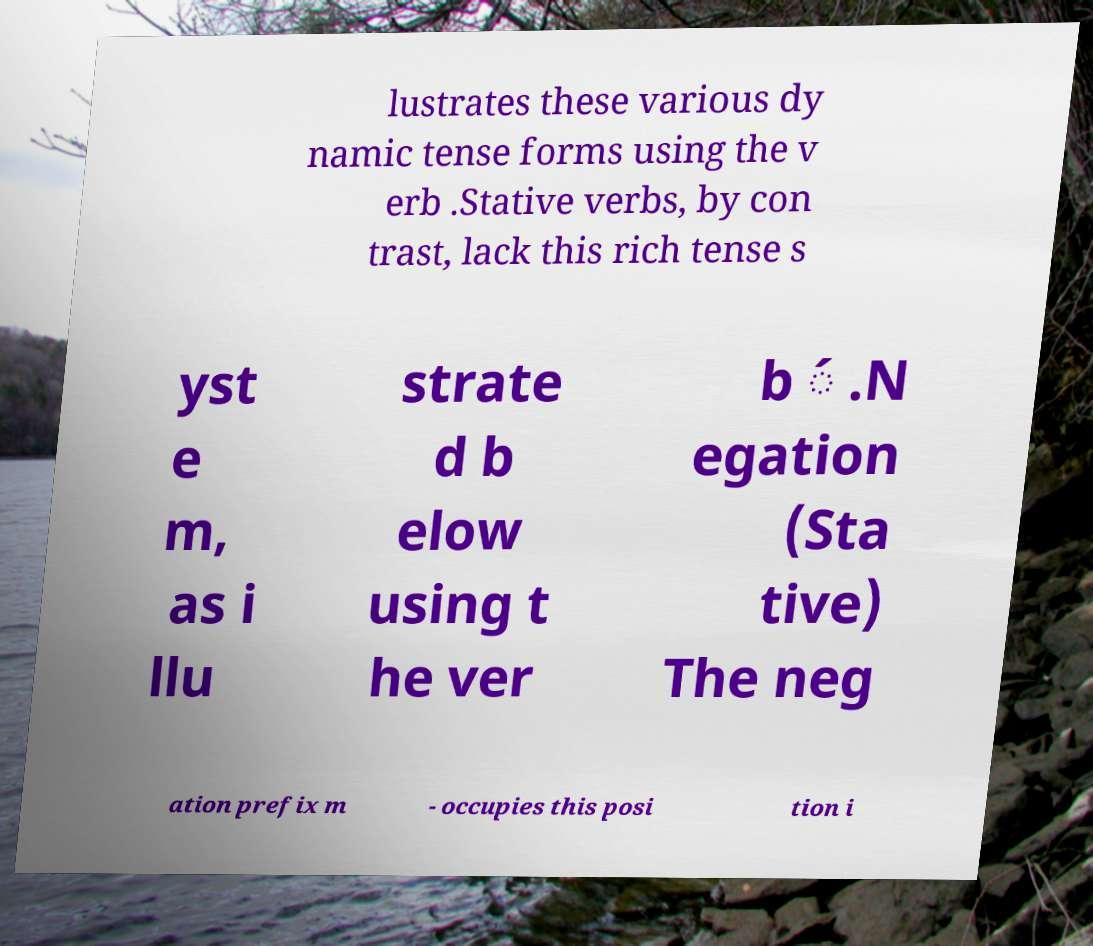Could you assist in decoding the text presented in this image and type it out clearly? lustrates these various dy namic tense forms using the v erb .Stative verbs, by con trast, lack this rich tense s yst e m, as i llu strate d b elow using t he ver b ́ .N egation (Sta tive) The neg ation prefix m - occupies this posi tion i 